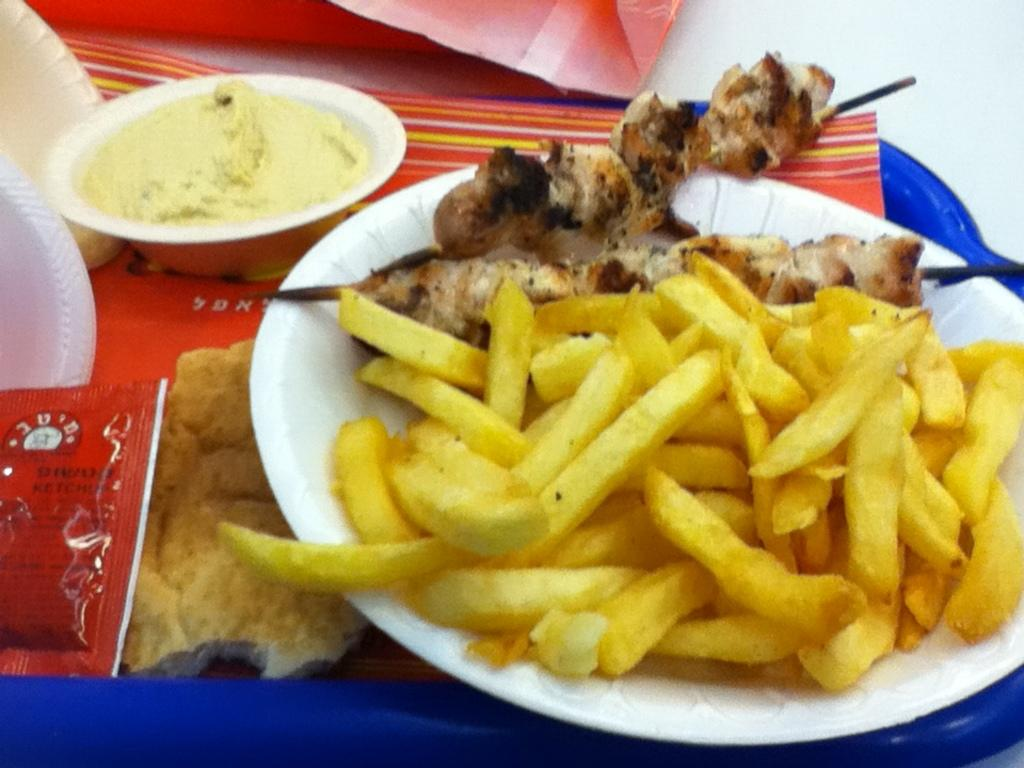What type of items can be seen in the image? There are food items in the image. What colors are the food items? The food is in yellow and brown colors. What color is the plate on which the food is placed? The plate is placed on a white color plate. What is the tray made of, and what color is it? The plate is placed in a blue color tray. How many ladybugs can be seen on the food items in the image? There are no ladybugs present in the image; it only features food items in yellow and brown colors on a white plate placed in a blue tray. 